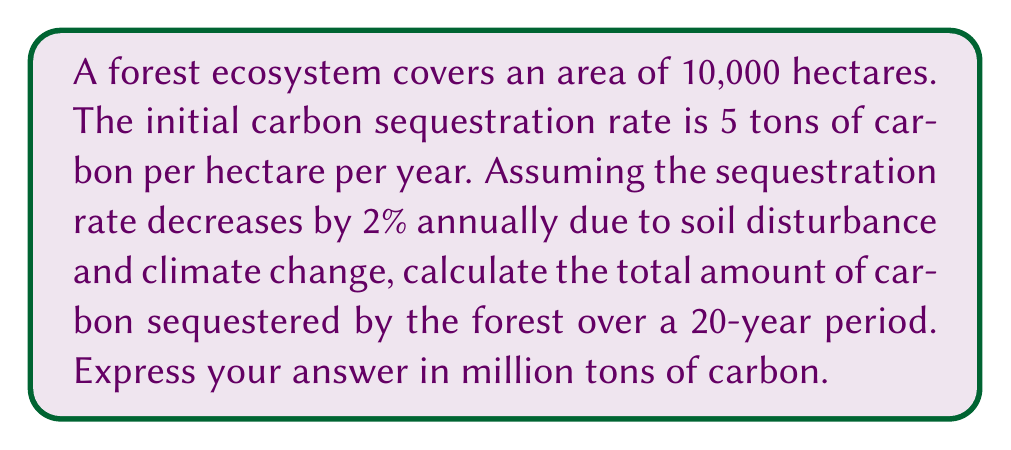Help me with this question. To solve this problem, we need to calculate the carbon sequestration for each year and sum them up over the 20-year period. Let's break it down step-by-step:

1. Initial sequestration rate: $r_0 = 5$ tons/hectare/year
2. Area of the forest: $A = 10,000$ hectares
3. Annual decrease rate: $d = 0.02$ (2%)
4. Time period: $T = 20$ years

The sequestration rate for year $t$ can be expressed as:
$$r_t = r_0 \cdot (1-d)^t$$

The carbon sequestered in year $t$ is:
$$C_t = A \cdot r_t = A \cdot r_0 \cdot (1-d)^t$$

The total carbon sequestered over 20 years is the sum of $C_t$ from $t=0$ to $t=19$:

$$C_{total} = \sum_{t=0}^{19} A \cdot r_0 \cdot (1-d)^t$$

This is a geometric series with first term $a = A \cdot r_0$ and common ratio $q = (1-d)$. The sum of a geometric series is given by:

$$S_n = a \cdot \frac{1-q^n}{1-q}$$

Where $n = 20$ (number of terms), $a = A \cdot r_0 = 10,000 \cdot 5 = 50,000$, and $q = (1-0.02) = 0.98$

Substituting these values:

$$C_{total} = 50,000 \cdot \frac{1-0.98^{20}}{1-0.98}$$

$$C_{total} = 50,000 \cdot \frac{1-0.6676}{0.02} = 832,979.21 \text{ tons}$$

Converting to million tons:

$$C_{total} = 832,979.21 \div 1,000,000 \approx 0.833 \text{ million tons}$$
Answer: 0.833 million tons of carbon 